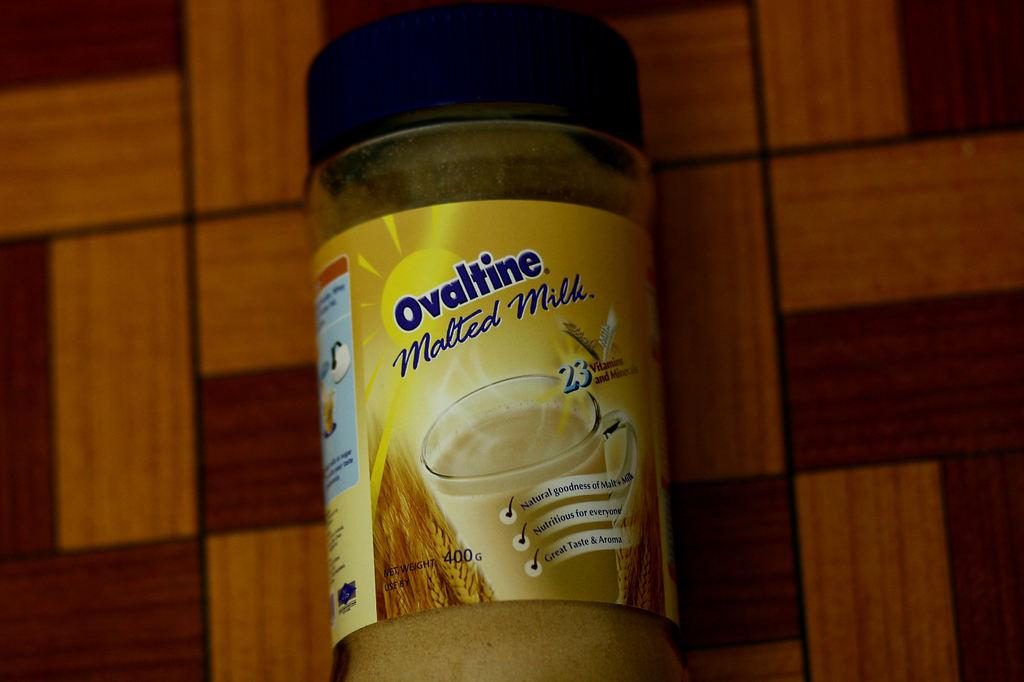Provide a one-sentence caption for the provided image. a bottle of ovaltine malted milk in blue. 